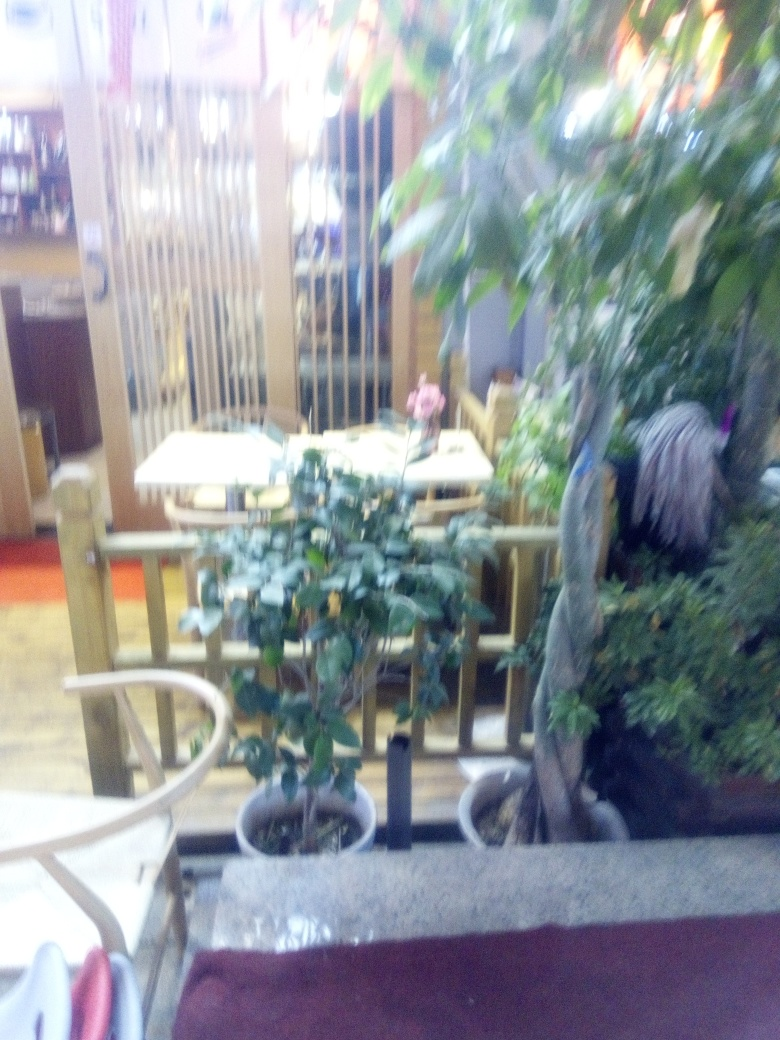Can you tell what time of day it might be in this image? It's difficult to determine the exact time of day from the image due to the lack of visible windows or natural light sources. The artificial lighting suggests it could be evening inside a dining area. 